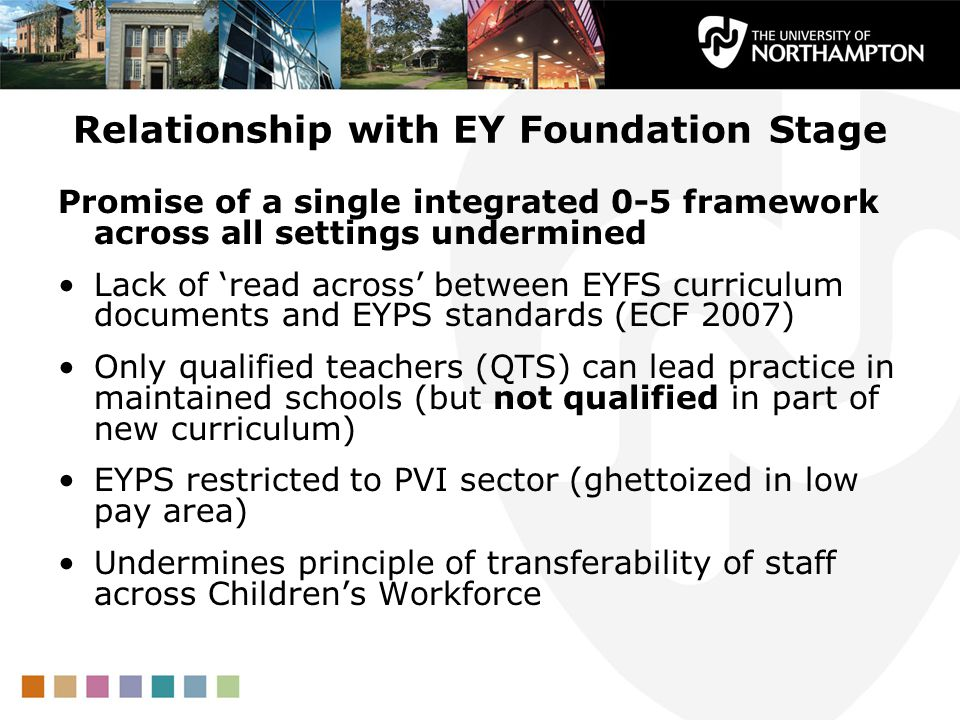Describe a futuristic scenario where technological advancements have resolved the issues in the EYFS framework. In a futuristic scenario, technological advancements have transformed the EYFS framework into a seamlessly integrated and adaptive system. Cutting-edge AI-driven platforms analyze, align, and synchronize curriculum documents with EYPS standards in real-time, ensuring uniformity and clarity for educators across all settings. Virtual reality (VR) and augmented reality (AR) tools provide interactive and immersive training programs, enabling educators to gain practical experience and acquire new qualifications efficiently. Blockchain technology ensures transparent and equitable compensation structures, bridging pay disparities between different sectors. Digital portfolios and personalized learning analytics track each child’s progress, offering tailored educational strategies that adapt to their unique needs. This futuristic EYFS framework fosters a harmonious, high-quality educational environment where every educator feels supported and every child receives the best start to their learning journey. 